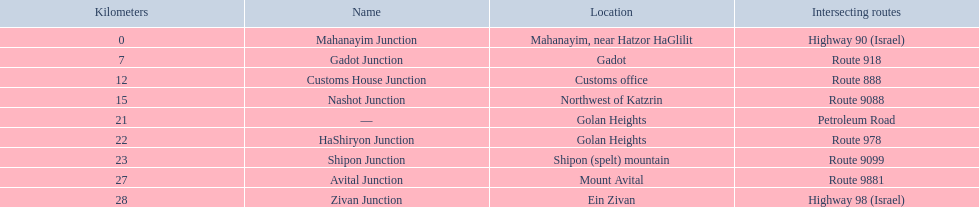What is the last junction on highway 91? Zivan Junction. 